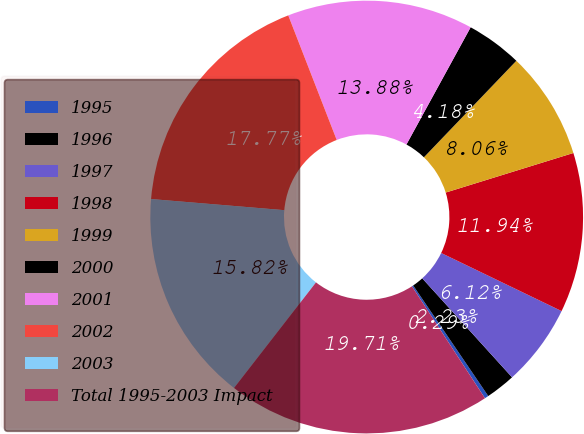<chart> <loc_0><loc_0><loc_500><loc_500><pie_chart><fcel>1995<fcel>1996<fcel>1997<fcel>1998<fcel>1999<fcel>2000<fcel>2001<fcel>2002<fcel>2003<fcel>Total 1995-2003 Impact<nl><fcel>0.29%<fcel>2.23%<fcel>6.12%<fcel>11.94%<fcel>8.06%<fcel>4.18%<fcel>13.88%<fcel>17.77%<fcel>15.82%<fcel>19.71%<nl></chart> 